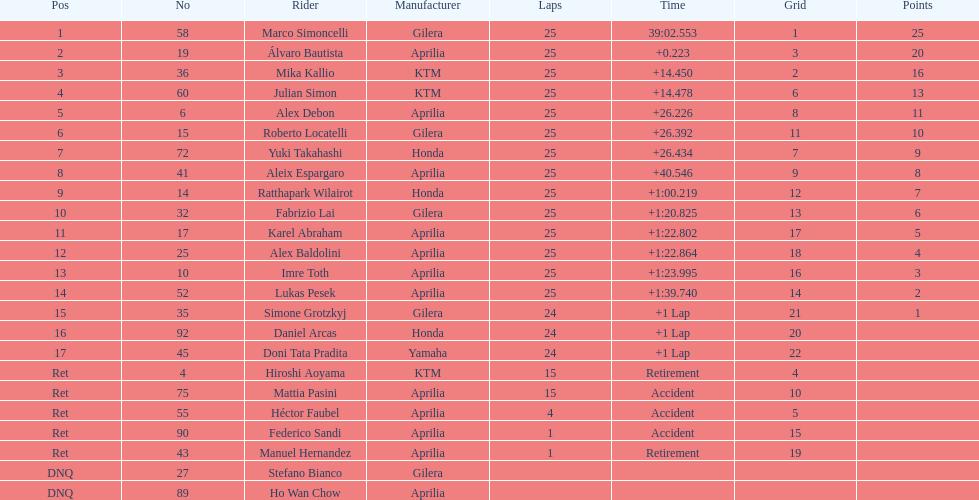Would you mind parsing the complete table? {'header': ['Pos', 'No', 'Rider', 'Manufacturer', 'Laps', 'Time', 'Grid', 'Points'], 'rows': [['1', '58', 'Marco Simoncelli', 'Gilera', '25', '39:02.553', '1', '25'], ['2', '19', 'Álvaro Bautista', 'Aprilia', '25', '+0.223', '3', '20'], ['3', '36', 'Mika Kallio', 'KTM', '25', '+14.450', '2', '16'], ['4', '60', 'Julian Simon', 'KTM', '25', '+14.478', '6', '13'], ['5', '6', 'Alex Debon', 'Aprilia', '25', '+26.226', '8', '11'], ['6', '15', 'Roberto Locatelli', 'Gilera', '25', '+26.392', '11', '10'], ['7', '72', 'Yuki Takahashi', 'Honda', '25', '+26.434', '7', '9'], ['8', '41', 'Aleix Espargaro', 'Aprilia', '25', '+40.546', '9', '8'], ['9', '14', 'Ratthapark Wilairot', 'Honda', '25', '+1:00.219', '12', '7'], ['10', '32', 'Fabrizio Lai', 'Gilera', '25', '+1:20.825', '13', '6'], ['11', '17', 'Karel Abraham', 'Aprilia', '25', '+1:22.802', '17', '5'], ['12', '25', 'Alex Baldolini', 'Aprilia', '25', '+1:22.864', '18', '4'], ['13', '10', 'Imre Toth', 'Aprilia', '25', '+1:23.995', '16', '3'], ['14', '52', 'Lukas Pesek', 'Aprilia', '25', '+1:39.740', '14', '2'], ['15', '35', 'Simone Grotzkyj', 'Gilera', '24', '+1 Lap', '21', '1'], ['16', '92', 'Daniel Arcas', 'Honda', '24', '+1 Lap', '20', ''], ['17', '45', 'Doni Tata Pradita', 'Yamaha', '24', '+1 Lap', '22', ''], ['Ret', '4', 'Hiroshi Aoyama', 'KTM', '15', 'Retirement', '4', ''], ['Ret', '75', 'Mattia Pasini', 'Aprilia', '15', 'Accident', '10', ''], ['Ret', '55', 'Héctor Faubel', 'Aprilia', '4', 'Accident', '5', ''], ['Ret', '90', 'Federico Sandi', 'Aprilia', '1', 'Accident', '15', ''], ['Ret', '43', 'Manuel Hernandez', 'Aprilia', '1', 'Retirement', '19', ''], ['DNQ', '27', 'Stefano Bianco', 'Gilera', '', '', '', ''], ['DNQ', '89', 'Ho Wan Chow', 'Aprilia', '', '', '', '']]} The ensuing racer from italy other than the triumphant marco simoncelli was Roberto Locatelli. 